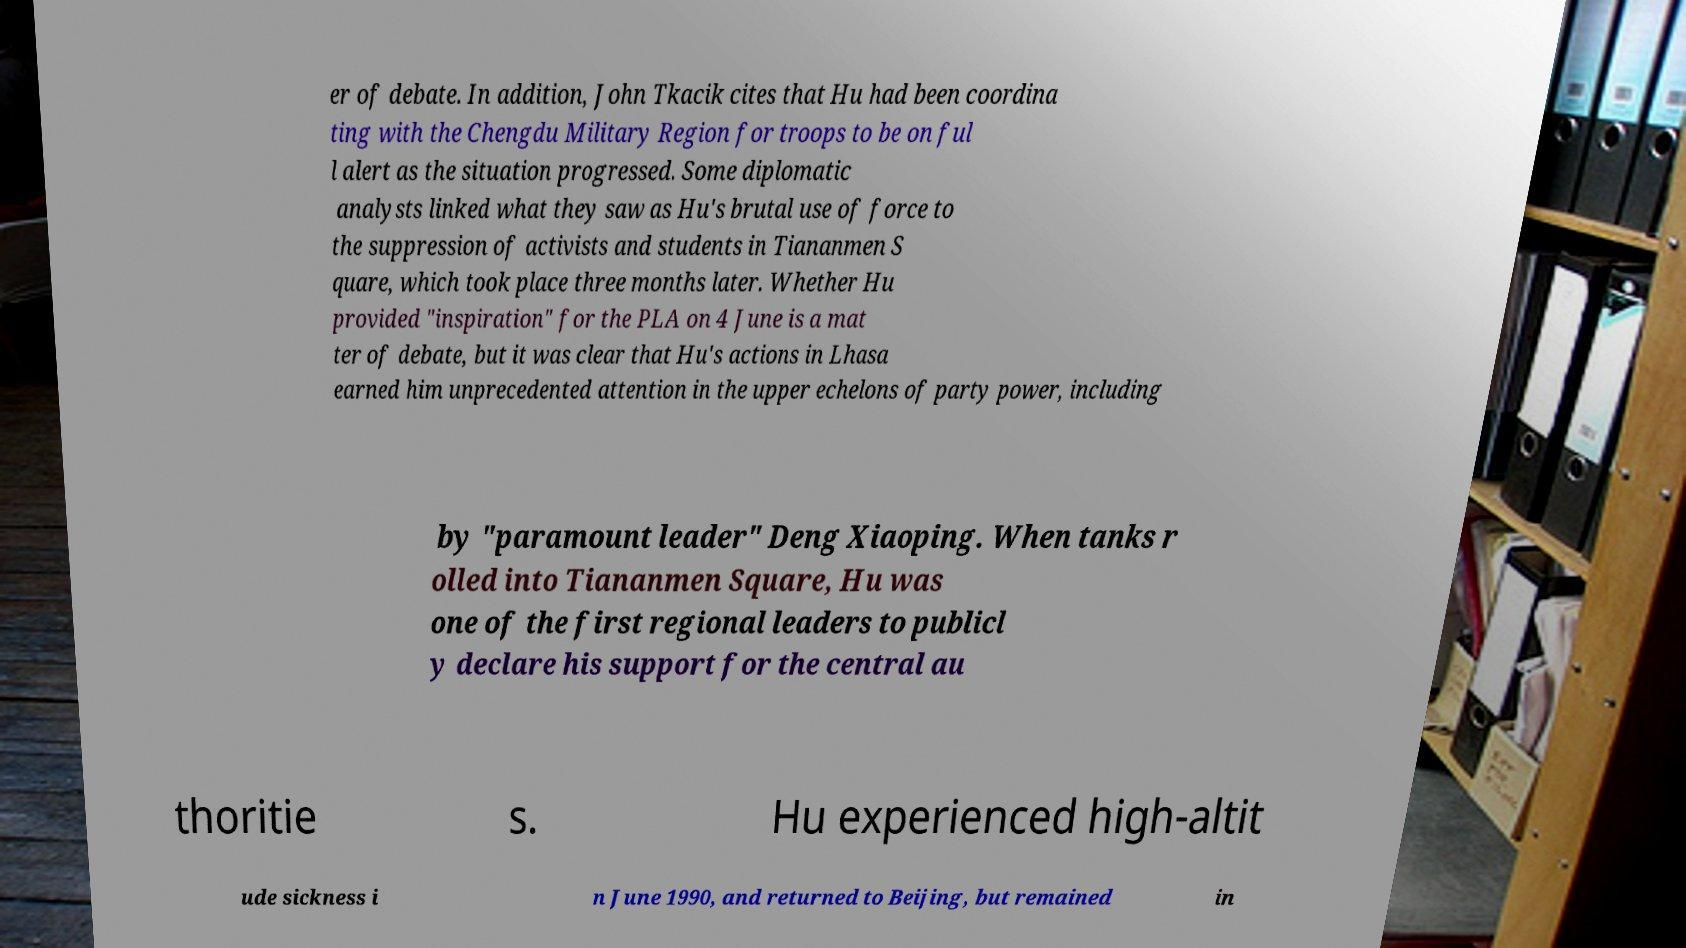Could you assist in decoding the text presented in this image and type it out clearly? er of debate. In addition, John Tkacik cites that Hu had been coordina ting with the Chengdu Military Region for troops to be on ful l alert as the situation progressed. Some diplomatic analysts linked what they saw as Hu's brutal use of force to the suppression of activists and students in Tiananmen S quare, which took place three months later. Whether Hu provided "inspiration" for the PLA on 4 June is a mat ter of debate, but it was clear that Hu's actions in Lhasa earned him unprecedented attention in the upper echelons of party power, including by "paramount leader" Deng Xiaoping. When tanks r olled into Tiananmen Square, Hu was one of the first regional leaders to publicl y declare his support for the central au thoritie s. Hu experienced high-altit ude sickness i n June 1990, and returned to Beijing, but remained in 